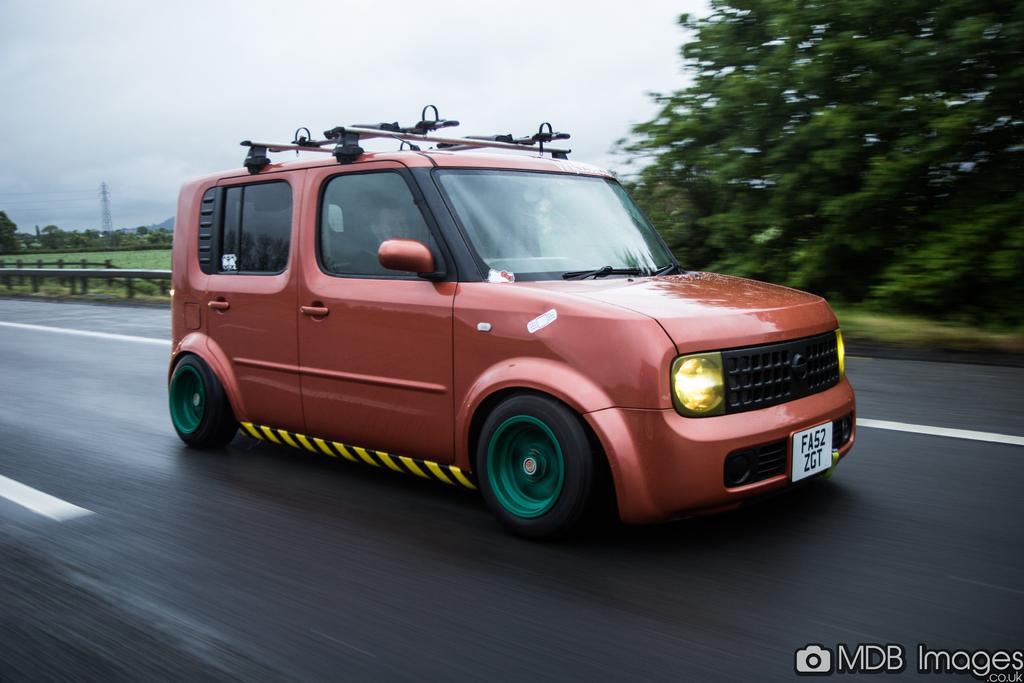What is the main subject in the middle of the image? There is a car in the middle of the image. What can be found at the bottom of the image? There is text and a road at the bottom of the image. What is visible in the background of the image? There are trees, a tower, cables, grass, a hill, and the sky in the background of the image. What is the condition of the sky in the image? The sky is visible in the background of the image, and there are clouds present. How does the beginner learn to rub the car in the image? There is no indication in the image that a beginner is learning to rub the car, and therefore no such activity can be observed. 